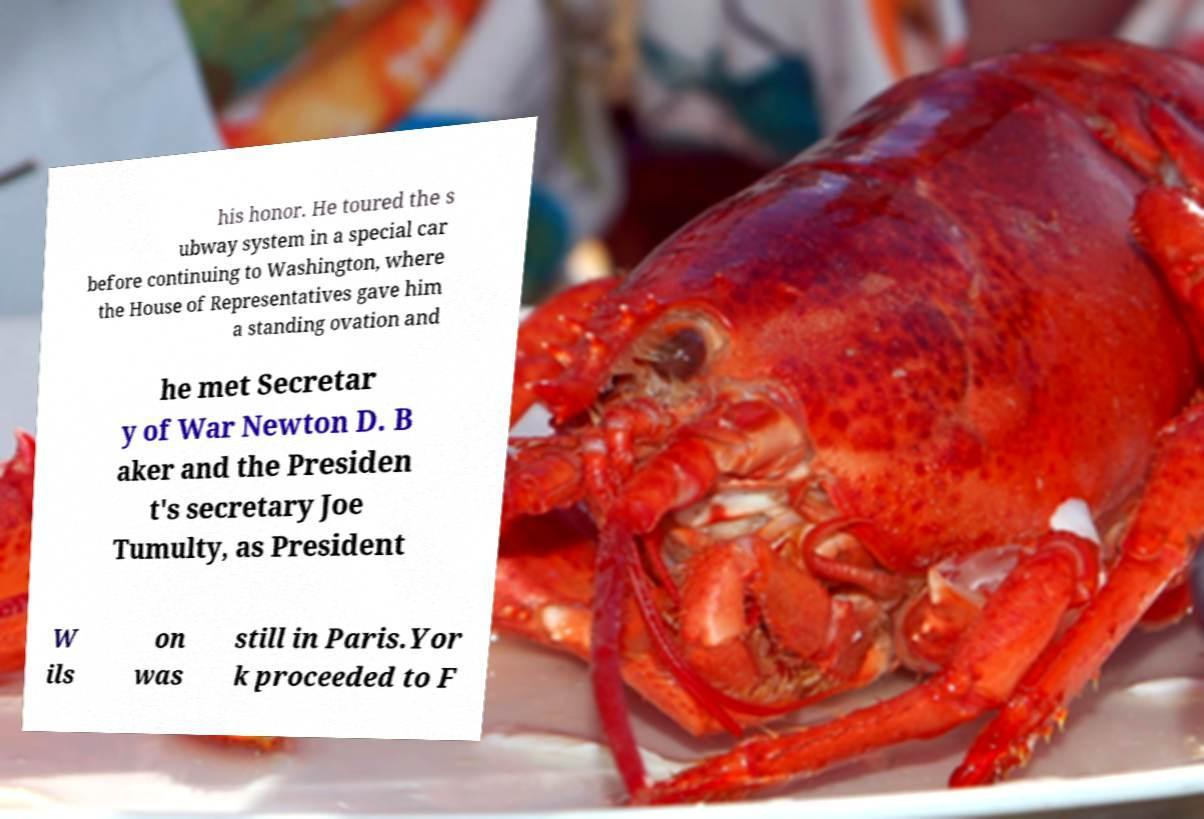There's text embedded in this image that I need extracted. Can you transcribe it verbatim? his honor. He toured the s ubway system in a special car before continuing to Washington, where the House of Representatives gave him a standing ovation and he met Secretar y of War Newton D. B aker and the Presiden t's secretary Joe Tumulty, as President W ils on was still in Paris.Yor k proceeded to F 